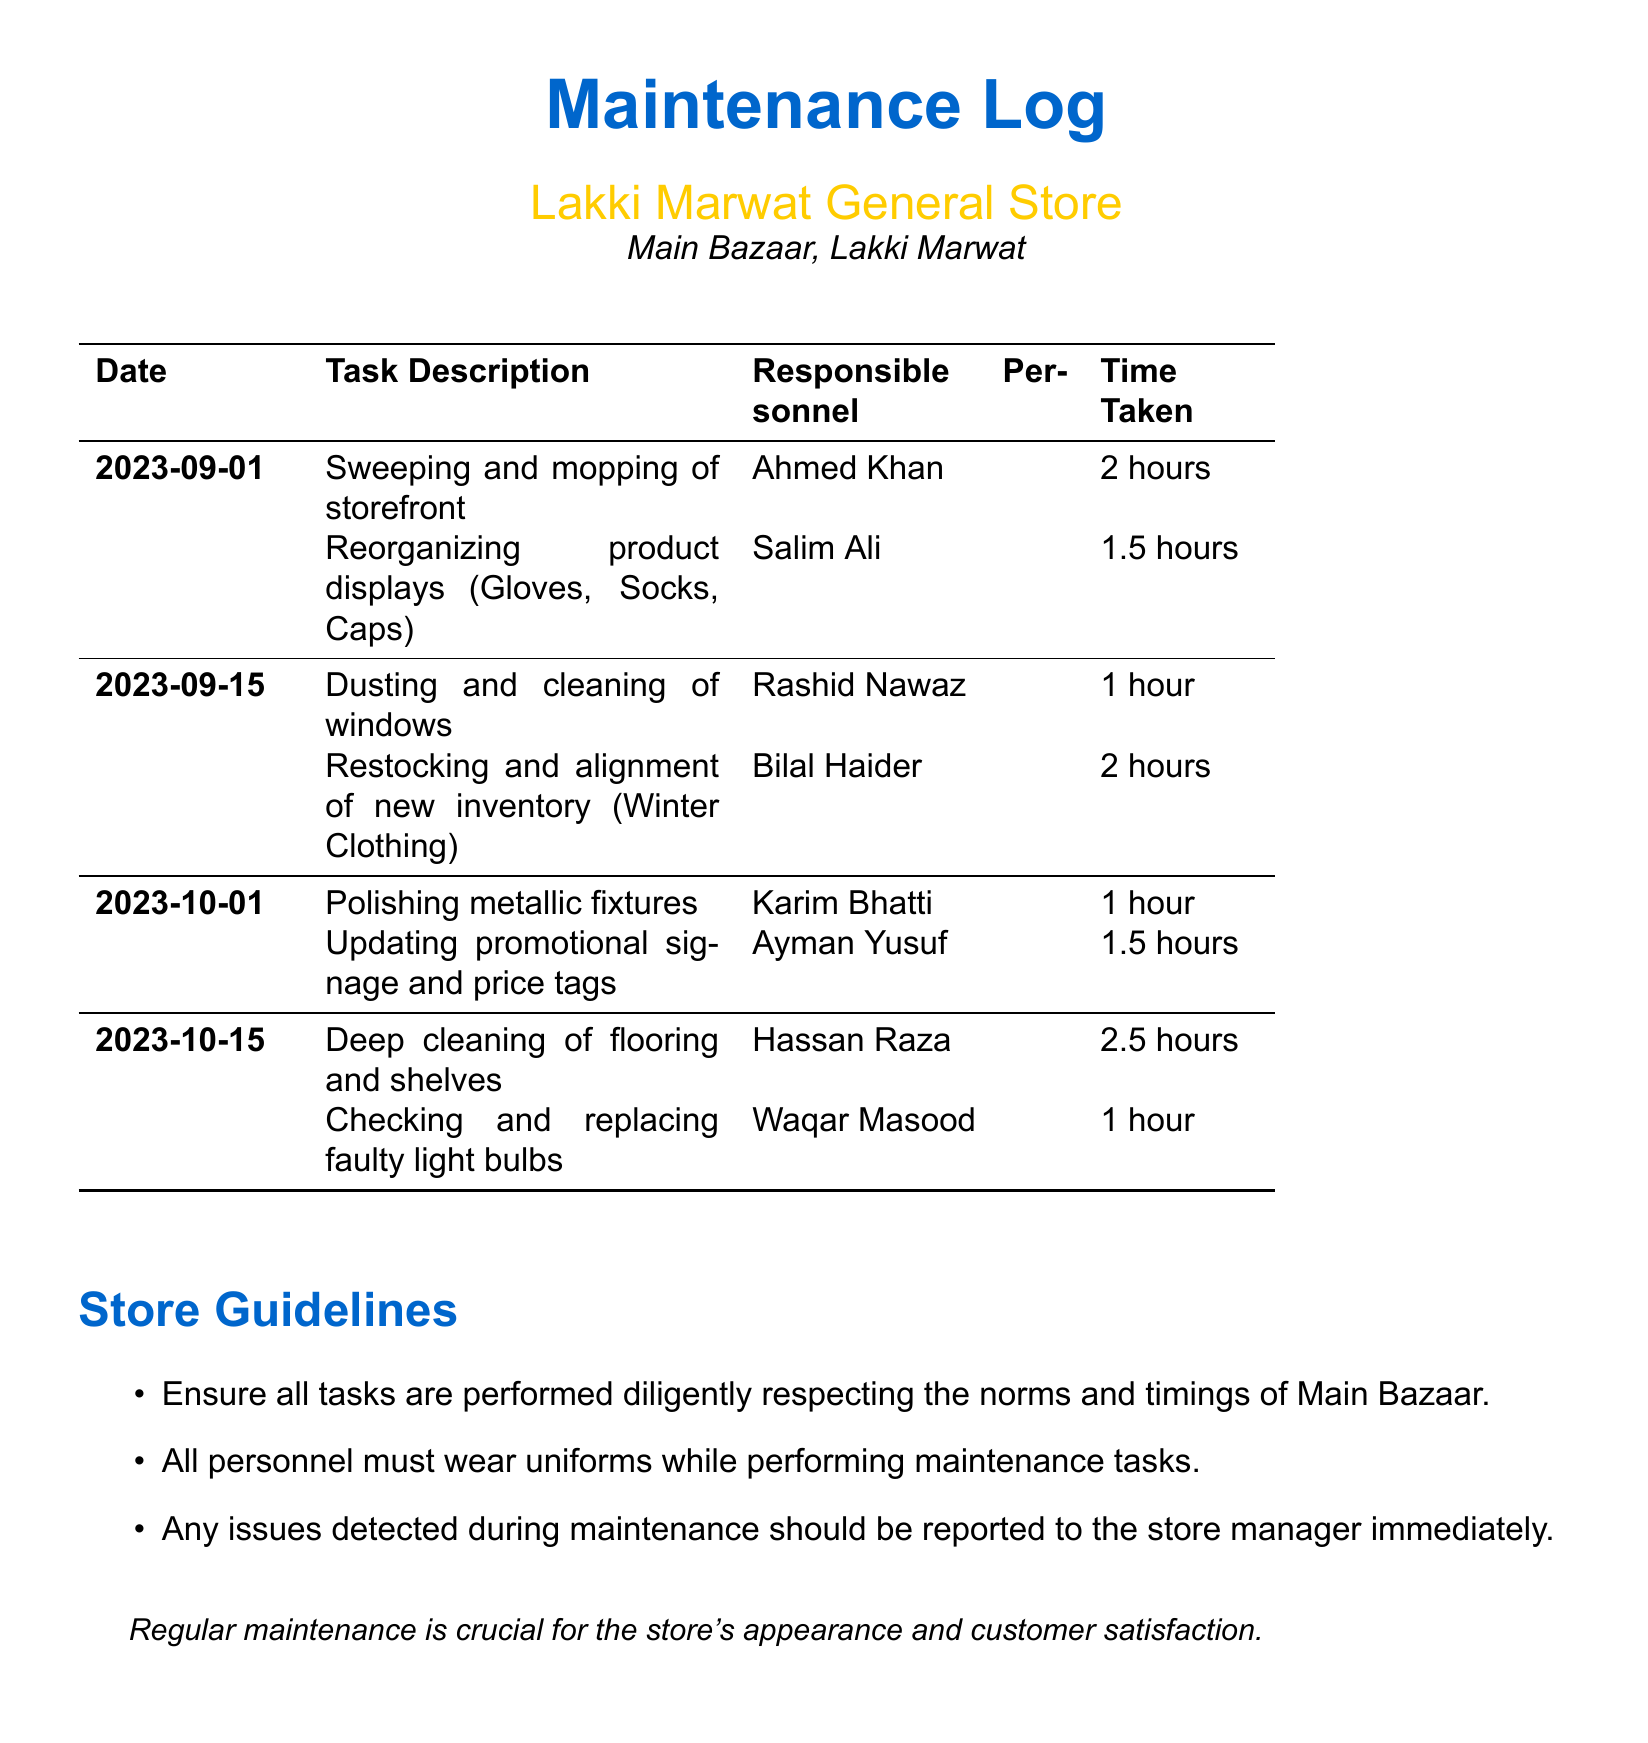What is the date of the first maintenance task? The first maintenance task logged in the document is recorded on September 1, 2023.
Answer: September 1, 2023 Who is responsible for polishing metallic fixtures? The task of polishing metallic fixtures is assigned to Karim Bhatti as stated in the document.
Answer: Karim Bhatti How long did it take to reorganize the product displays on September 1? The time taken for reorganizing product displays (Gloves, Socks, Caps) on September 1 was 1.5 hours.
Answer: 1.5 hours What was the last task completed on October 15? The last task completed on October 15 was checking and replacing faulty light bulbs as recorded in the log.
Answer: Checking and replacing faulty light bulbs How many hours were spent on deep cleaning of flooring and shelves? The deep cleaning of flooring and shelves took 2.5 hours as mentioned in the log.
Answer: 2.5 hours What is one guideline mentioned for maintenance tasks? The document lists several guidelines, one of which is that all personnel must wear uniforms while performing maintenance tasks.
Answer: All personnel must wear uniforms Who was responsible for updating promotional signage and price tags? The task of updating promotional signage and price tags was assigned to Ayman Yusuf according to the document.
Answer: Ayman Yusuf What is the total time taken for the maintenance tasks on September 15? The total time taken for tasks on September 15 is the sum of 1 hour for dusting and cleaning of windows and 2 hours for restocking, which equals 3 hours.
Answer: 3 hours 